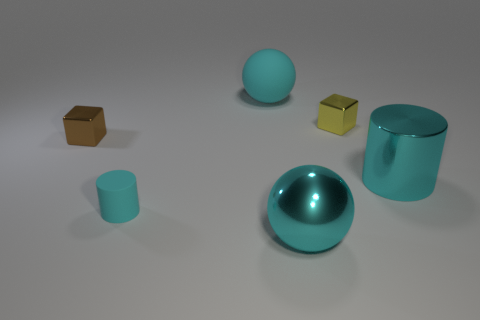Add 4 large green matte things. How many objects exist? 10 Subtract all blocks. How many objects are left? 4 Add 2 blue metallic things. How many blue metallic things exist? 2 Subtract 1 cyan balls. How many objects are left? 5 Subtract all yellow cubes. Subtract all green balls. How many cubes are left? 1 Subtract all small cyan matte objects. Subtract all big cyan metal cylinders. How many objects are left? 4 Add 4 spheres. How many spheres are left? 6 